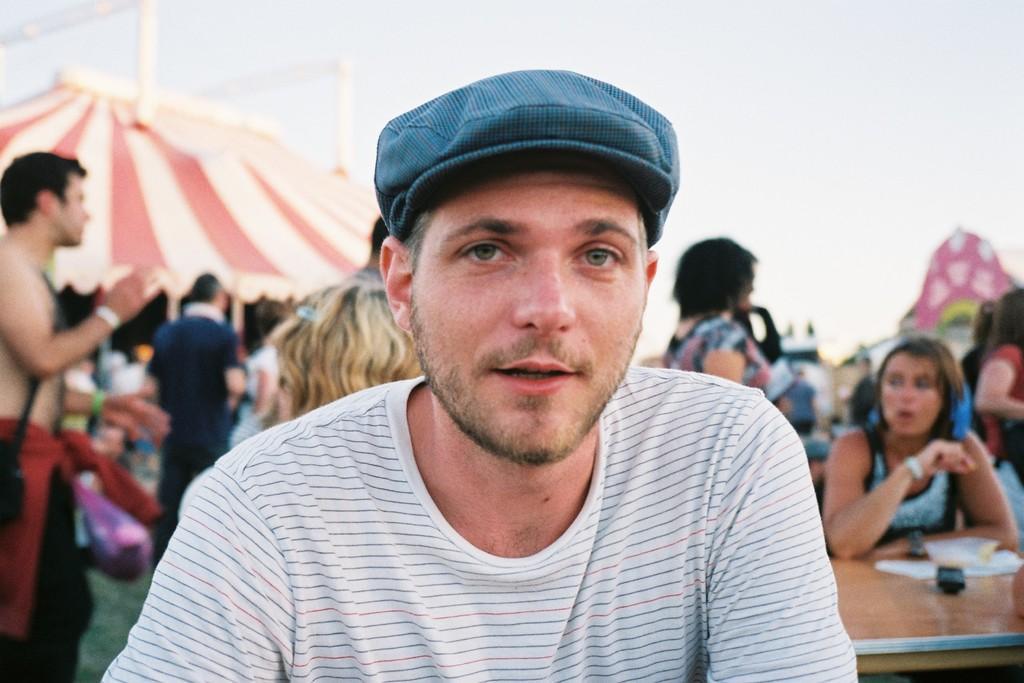How would you summarize this image in a sentence or two? This picture shows few people standing and few are seated and we see a man wore cap on his head and we see tent and a cloudy sky and we see few papers on the table. 